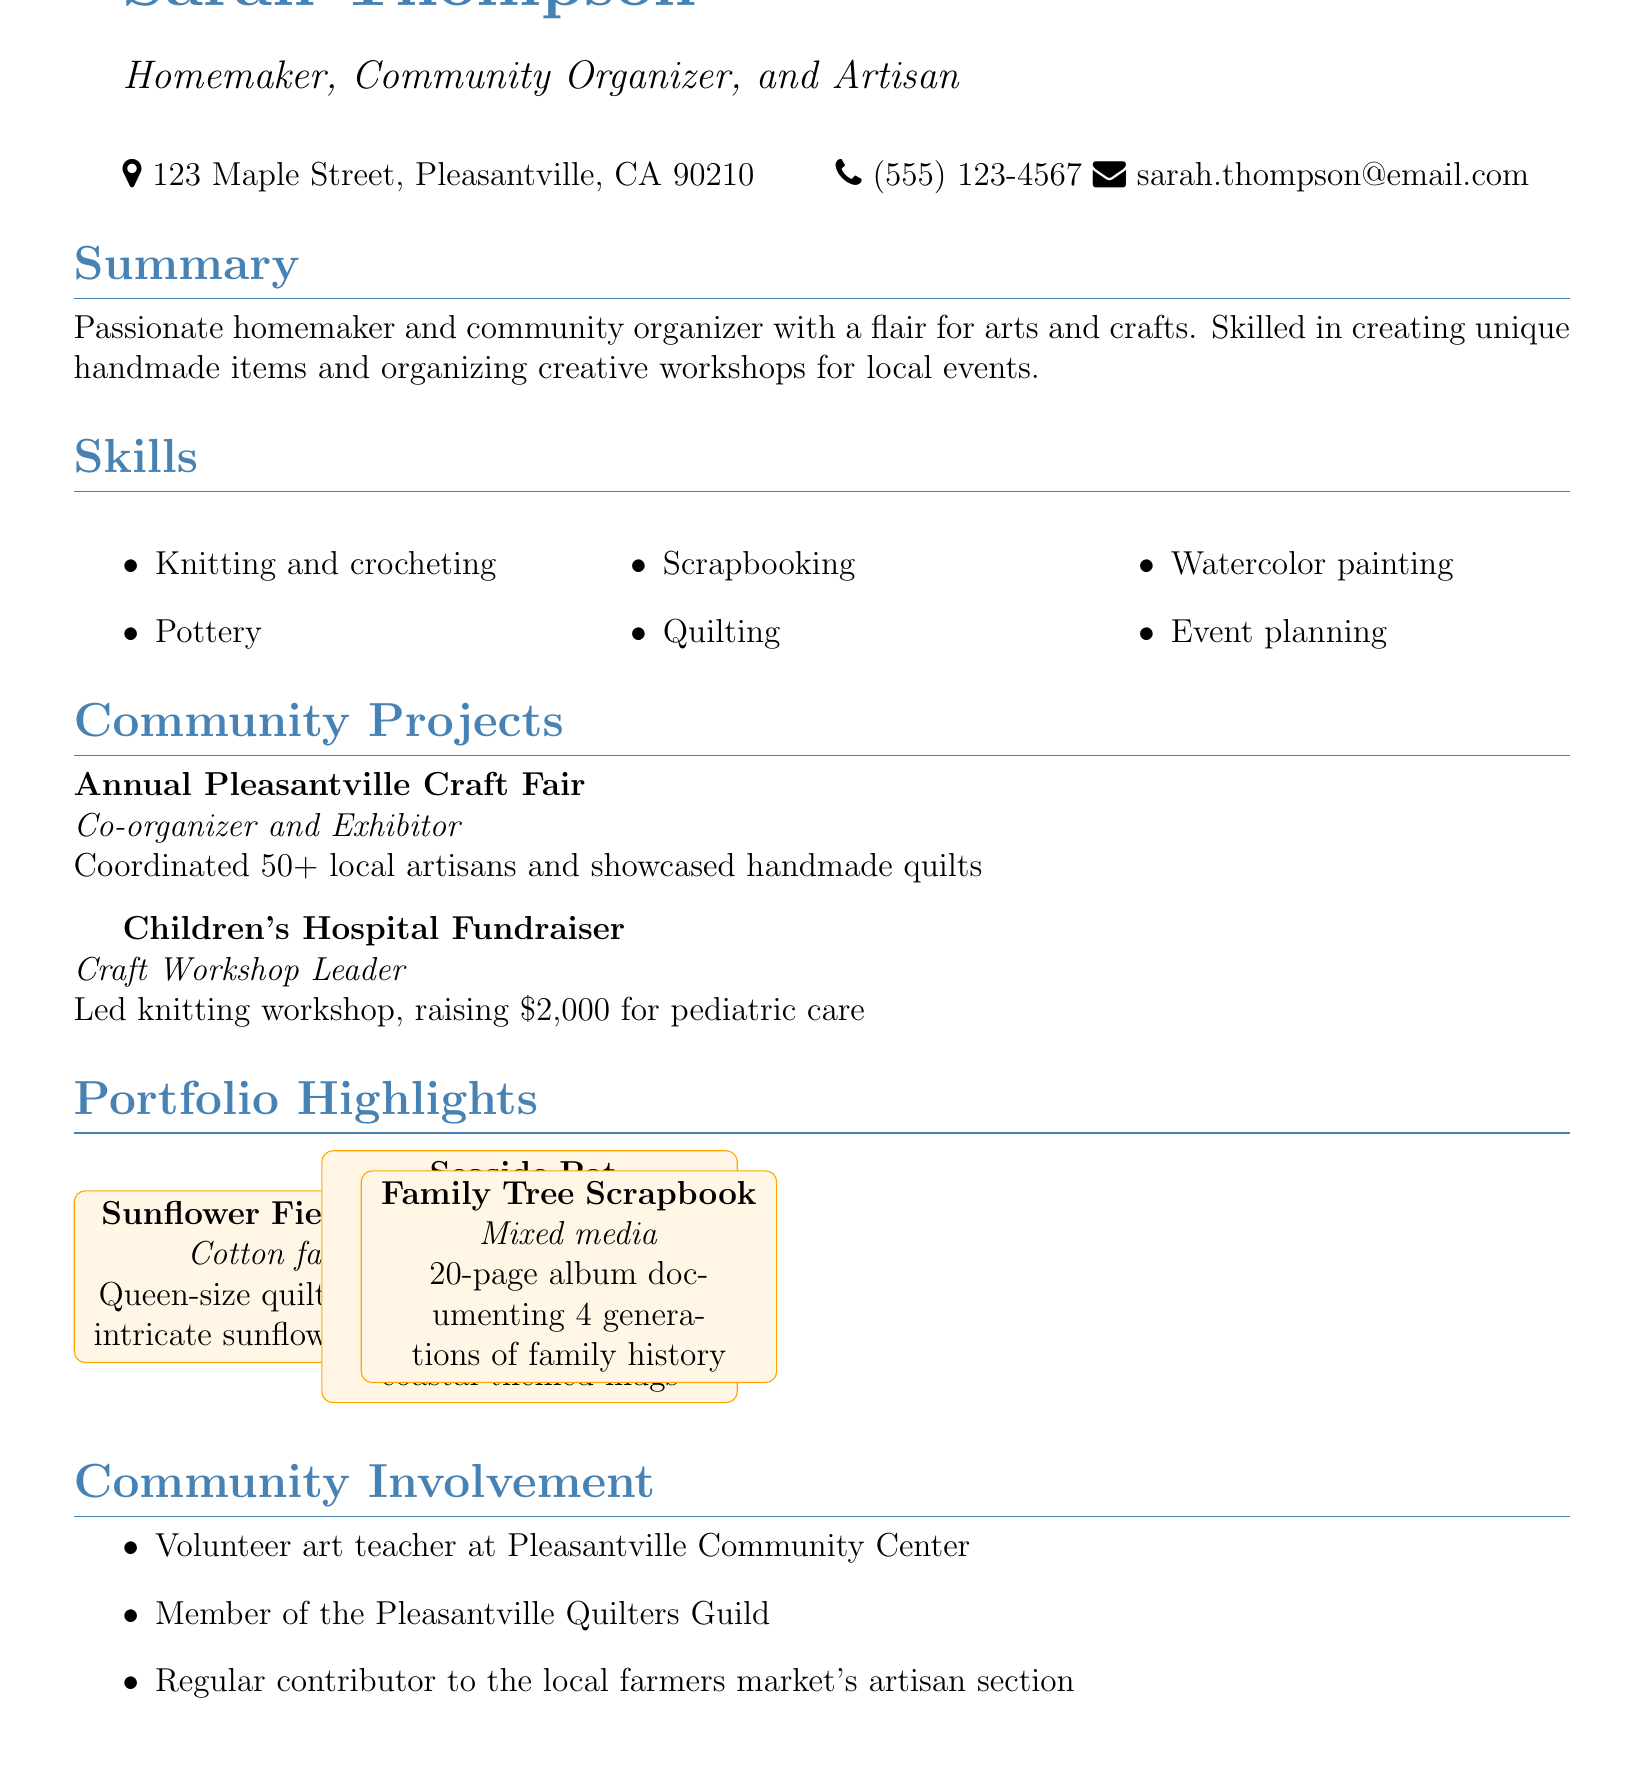What is Sarah Thompson's email address? The email address listed in the document is used for contact information.
Answer: sarah.thompson@email.com How many local artisans were coordinated for the craft fair? The document states that Sarah coordinated over 50 local artisans for the event.
Answer: 50+ What role did Sarah have in the Children's Hospital Fundraiser? The document specifies her role during the fundraiser, which reflects her involvement in the event.
Answer: Craft Workshop Leader What is the medium of the Sunflower Fields Quilt? The document provides information about the materials used for each portfolio highlight.
Answer: Cotton fabric How much money was raised during the knitting workshop? The fundraising amount is explicitly mentioned in the description of the workshop.
Answer: $2,000 What community organization is Sarah a member of? This question explores her involvement in local community organizations highlighted in her CV.
Answer: Pleasantville Quilters Guild What type of craft is showcased in the Seaside Pottery Collection? The document describes the items in the portfolio, focusing on the craft technique used.
Answer: Stoneware clay How many pages is the Family Tree Scrapbook? The document specifies the length of the scrapbook, indicating its size.
Answer: 20-page What is Sarah's primary area of expertise? The summary highlights her main competencies, combining her personal and professional interests.
Answer: Arts and crafts 